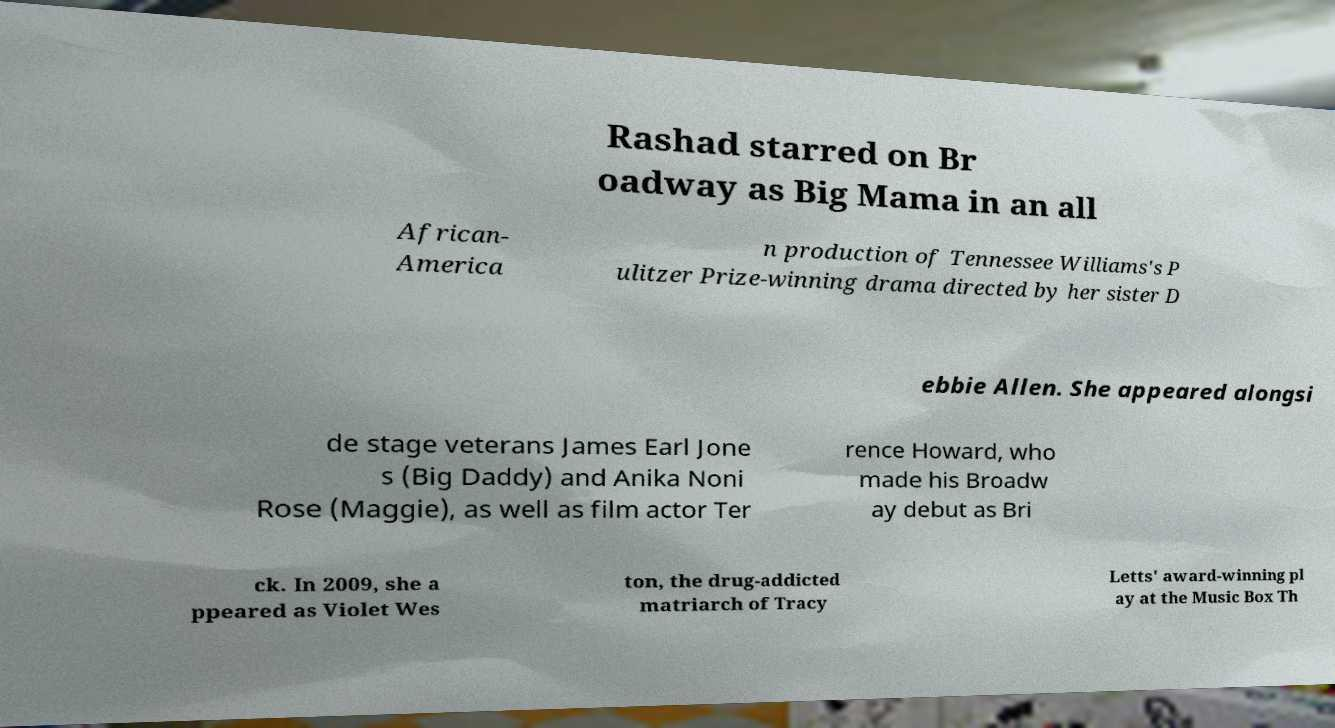Could you extract and type out the text from this image? Rashad starred on Br oadway as Big Mama in an all African- America n production of Tennessee Williams's P ulitzer Prize-winning drama directed by her sister D ebbie Allen. She appeared alongsi de stage veterans James Earl Jone s (Big Daddy) and Anika Noni Rose (Maggie), as well as film actor Ter rence Howard, who made his Broadw ay debut as Bri ck. In 2009, she a ppeared as Violet Wes ton, the drug-addicted matriarch of Tracy Letts' award-winning pl ay at the Music Box Th 